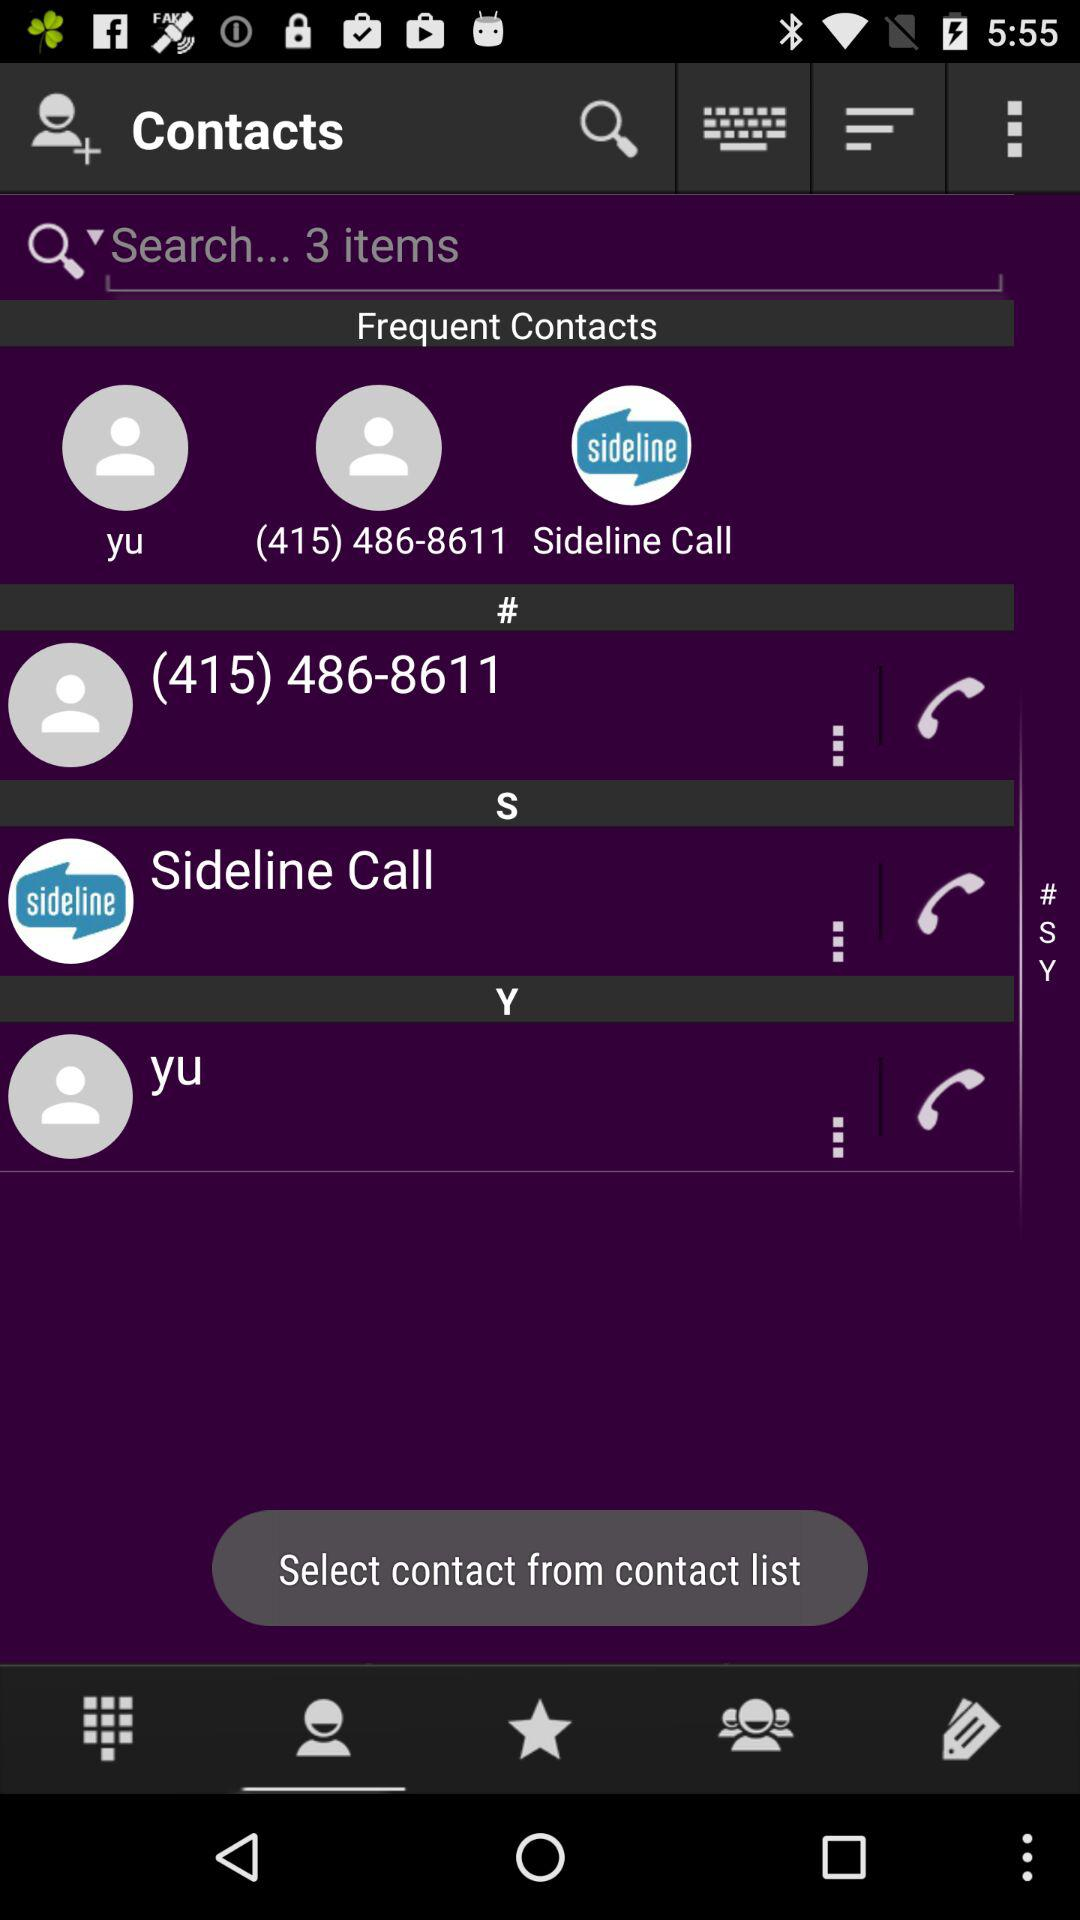What is the phone number? The phone number is (415) 486-8611. 